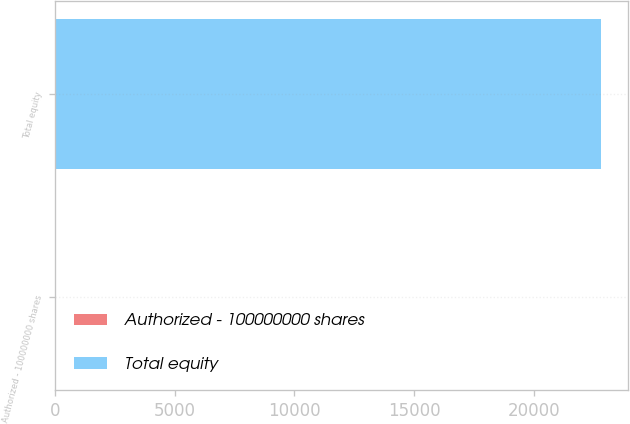Convert chart to OTSL. <chart><loc_0><loc_0><loc_500><loc_500><bar_chart><fcel>Authorized - 100000000 shares<fcel>Total equity<nl><fcel>3<fcel>22810<nl></chart> 